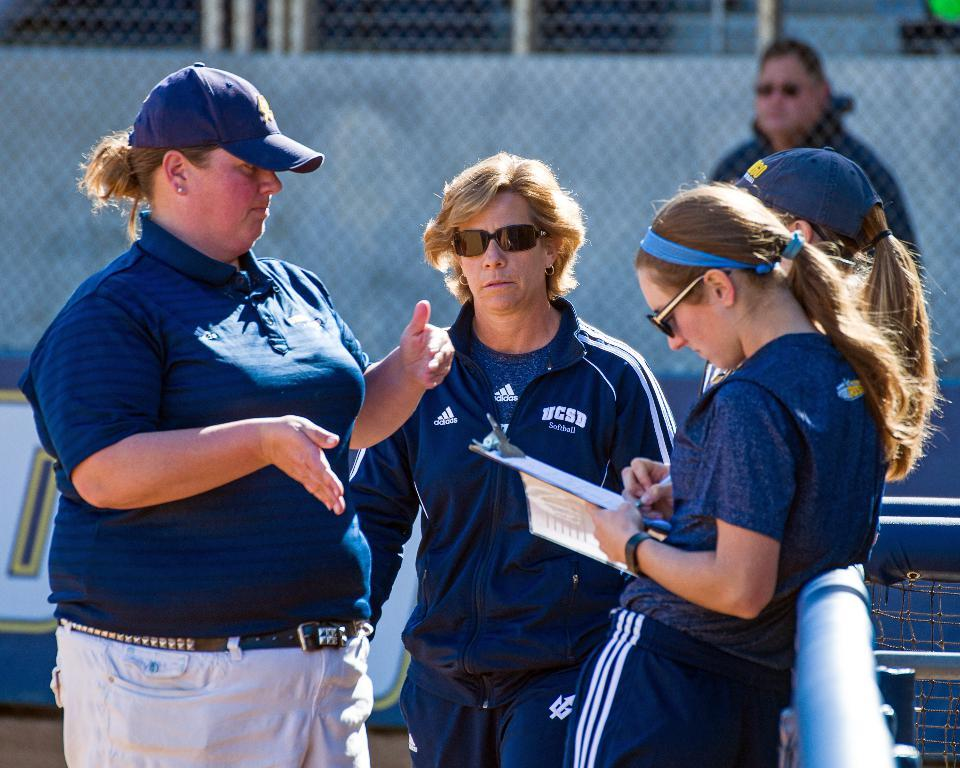<image>
Share a concise interpretation of the image provided. Three women in UCSD uniforms talking to each other. 